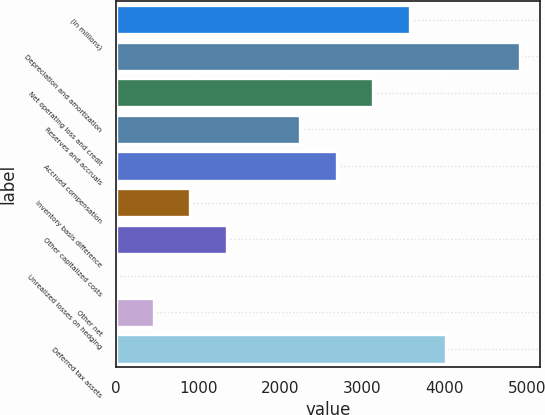<chart> <loc_0><loc_0><loc_500><loc_500><bar_chart><fcel>(In millions)<fcel>Depreciation and amortization<fcel>Net operating loss and credit<fcel>Reserves and accruals<fcel>Accrued compensation<fcel>Inventory basis difference<fcel>Other capitalized costs<fcel>Unrealized losses on hedging<fcel>Other net<fcel>Deferred tax assets<nl><fcel>3577.6<fcel>4914.4<fcel>3132<fcel>2240.8<fcel>2686.4<fcel>904<fcel>1349.6<fcel>12.8<fcel>458.4<fcel>4023.2<nl></chart> 